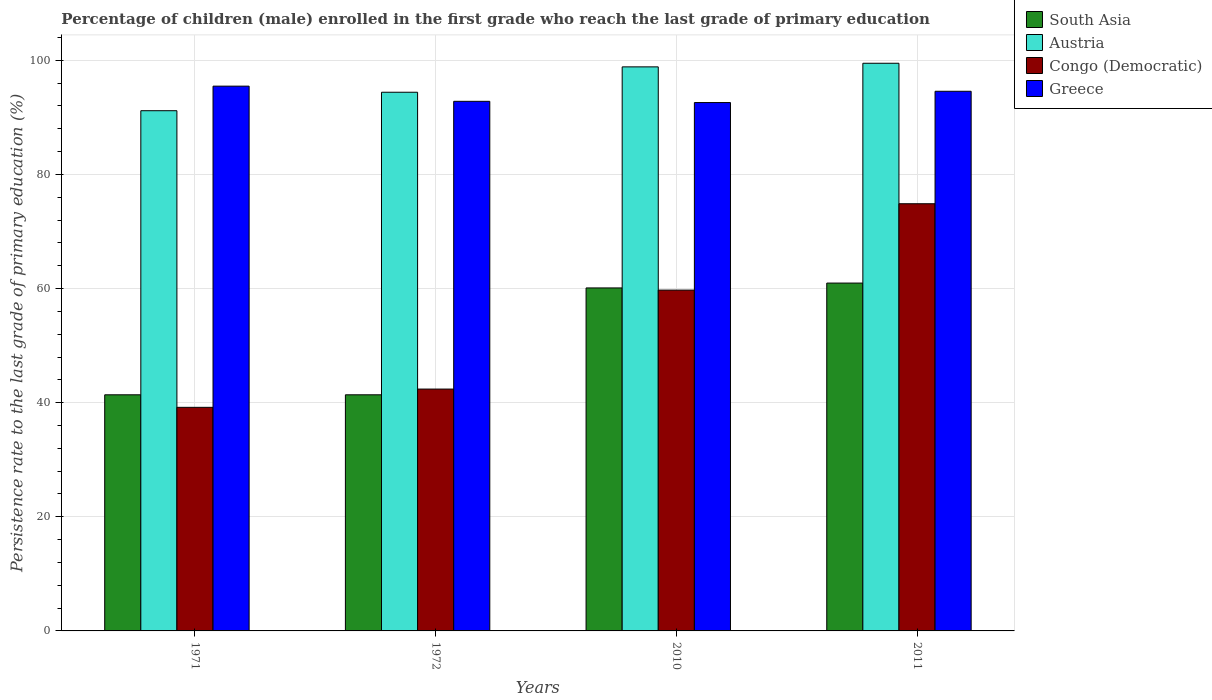How many different coloured bars are there?
Your answer should be very brief. 4. Are the number of bars on each tick of the X-axis equal?
Your response must be concise. Yes. How many bars are there on the 4th tick from the left?
Provide a short and direct response. 4. What is the persistence rate of children in Congo (Democratic) in 1972?
Offer a very short reply. 42.39. Across all years, what is the maximum persistence rate of children in Greece?
Your response must be concise. 95.48. Across all years, what is the minimum persistence rate of children in Congo (Democratic)?
Give a very brief answer. 39.19. In which year was the persistence rate of children in South Asia maximum?
Provide a short and direct response. 2011. In which year was the persistence rate of children in Congo (Democratic) minimum?
Offer a very short reply. 1971. What is the total persistence rate of children in Greece in the graph?
Give a very brief answer. 375.48. What is the difference between the persistence rate of children in South Asia in 1972 and that in 2011?
Offer a terse response. -19.58. What is the difference between the persistence rate of children in Austria in 2011 and the persistence rate of children in Congo (Democratic) in 2010?
Make the answer very short. 39.76. What is the average persistence rate of children in South Asia per year?
Offer a terse response. 50.96. In the year 2011, what is the difference between the persistence rate of children in Congo (Democratic) and persistence rate of children in Greece?
Your answer should be compact. -19.71. In how many years, is the persistence rate of children in Austria greater than 4 %?
Your answer should be compact. 4. What is the ratio of the persistence rate of children in Austria in 1972 to that in 2010?
Provide a succinct answer. 0.95. Is the difference between the persistence rate of children in Congo (Democratic) in 1971 and 2010 greater than the difference between the persistence rate of children in Greece in 1971 and 2010?
Provide a short and direct response. No. What is the difference between the highest and the second highest persistence rate of children in Austria?
Keep it short and to the point. 0.63. What is the difference between the highest and the lowest persistence rate of children in Greece?
Make the answer very short. 2.87. Is it the case that in every year, the sum of the persistence rate of children in Congo (Democratic) and persistence rate of children in South Asia is greater than the sum of persistence rate of children in Austria and persistence rate of children in Greece?
Offer a terse response. No. What does the 2nd bar from the left in 1972 represents?
Your answer should be very brief. Austria. What does the 3rd bar from the right in 2011 represents?
Your response must be concise. Austria. Is it the case that in every year, the sum of the persistence rate of children in Greece and persistence rate of children in Congo (Democratic) is greater than the persistence rate of children in Austria?
Your answer should be compact. Yes. Are all the bars in the graph horizontal?
Provide a succinct answer. No. How many years are there in the graph?
Provide a short and direct response. 4. What is the difference between two consecutive major ticks on the Y-axis?
Give a very brief answer. 20. Are the values on the major ticks of Y-axis written in scientific E-notation?
Give a very brief answer. No. Does the graph contain any zero values?
Offer a terse response. No. Does the graph contain grids?
Your answer should be compact. Yes. What is the title of the graph?
Give a very brief answer. Percentage of children (male) enrolled in the first grade who reach the last grade of primary education. What is the label or title of the X-axis?
Offer a very short reply. Years. What is the label or title of the Y-axis?
Your answer should be compact. Persistence rate to the last grade of primary education (%). What is the Persistence rate to the last grade of primary education (%) in South Asia in 1971?
Offer a very short reply. 41.38. What is the Persistence rate to the last grade of primary education (%) of Austria in 1971?
Your answer should be very brief. 91.17. What is the Persistence rate to the last grade of primary education (%) of Congo (Democratic) in 1971?
Provide a short and direct response. 39.19. What is the Persistence rate to the last grade of primary education (%) of Greece in 1971?
Ensure brevity in your answer.  95.48. What is the Persistence rate to the last grade of primary education (%) of South Asia in 1972?
Your answer should be compact. 41.38. What is the Persistence rate to the last grade of primary education (%) of Austria in 1972?
Your answer should be very brief. 94.41. What is the Persistence rate to the last grade of primary education (%) of Congo (Democratic) in 1972?
Provide a short and direct response. 42.39. What is the Persistence rate to the last grade of primary education (%) of Greece in 1972?
Give a very brief answer. 92.82. What is the Persistence rate to the last grade of primary education (%) in South Asia in 2010?
Make the answer very short. 60.11. What is the Persistence rate to the last grade of primary education (%) of Austria in 2010?
Make the answer very short. 98.86. What is the Persistence rate to the last grade of primary education (%) in Congo (Democratic) in 2010?
Offer a terse response. 59.73. What is the Persistence rate to the last grade of primary education (%) of Greece in 2010?
Your answer should be very brief. 92.6. What is the Persistence rate to the last grade of primary education (%) in South Asia in 2011?
Your response must be concise. 60.96. What is the Persistence rate to the last grade of primary education (%) in Austria in 2011?
Provide a short and direct response. 99.49. What is the Persistence rate to the last grade of primary education (%) in Congo (Democratic) in 2011?
Offer a very short reply. 74.87. What is the Persistence rate to the last grade of primary education (%) in Greece in 2011?
Provide a short and direct response. 94.58. Across all years, what is the maximum Persistence rate to the last grade of primary education (%) of South Asia?
Your answer should be very brief. 60.96. Across all years, what is the maximum Persistence rate to the last grade of primary education (%) of Austria?
Make the answer very short. 99.49. Across all years, what is the maximum Persistence rate to the last grade of primary education (%) of Congo (Democratic)?
Provide a short and direct response. 74.87. Across all years, what is the maximum Persistence rate to the last grade of primary education (%) in Greece?
Your answer should be compact. 95.48. Across all years, what is the minimum Persistence rate to the last grade of primary education (%) of South Asia?
Your answer should be compact. 41.38. Across all years, what is the minimum Persistence rate to the last grade of primary education (%) in Austria?
Your response must be concise. 91.17. Across all years, what is the minimum Persistence rate to the last grade of primary education (%) in Congo (Democratic)?
Make the answer very short. 39.19. Across all years, what is the minimum Persistence rate to the last grade of primary education (%) in Greece?
Provide a succinct answer. 92.6. What is the total Persistence rate to the last grade of primary education (%) of South Asia in the graph?
Your answer should be compact. 203.84. What is the total Persistence rate to the last grade of primary education (%) in Austria in the graph?
Provide a succinct answer. 383.93. What is the total Persistence rate to the last grade of primary education (%) in Congo (Democratic) in the graph?
Provide a succinct answer. 216.17. What is the total Persistence rate to the last grade of primary education (%) in Greece in the graph?
Give a very brief answer. 375.48. What is the difference between the Persistence rate to the last grade of primary education (%) in South Asia in 1971 and that in 1972?
Give a very brief answer. -0. What is the difference between the Persistence rate to the last grade of primary education (%) in Austria in 1971 and that in 1972?
Offer a very short reply. -3.24. What is the difference between the Persistence rate to the last grade of primary education (%) of Congo (Democratic) in 1971 and that in 1972?
Your response must be concise. -3.2. What is the difference between the Persistence rate to the last grade of primary education (%) in Greece in 1971 and that in 1972?
Your answer should be compact. 2.66. What is the difference between the Persistence rate to the last grade of primary education (%) in South Asia in 1971 and that in 2010?
Provide a succinct answer. -18.73. What is the difference between the Persistence rate to the last grade of primary education (%) of Austria in 1971 and that in 2010?
Offer a terse response. -7.68. What is the difference between the Persistence rate to the last grade of primary education (%) in Congo (Democratic) in 1971 and that in 2010?
Make the answer very short. -20.55. What is the difference between the Persistence rate to the last grade of primary education (%) in Greece in 1971 and that in 2010?
Your answer should be very brief. 2.87. What is the difference between the Persistence rate to the last grade of primary education (%) of South Asia in 1971 and that in 2011?
Offer a very short reply. -19.58. What is the difference between the Persistence rate to the last grade of primary education (%) in Austria in 1971 and that in 2011?
Your answer should be compact. -8.32. What is the difference between the Persistence rate to the last grade of primary education (%) of Congo (Democratic) in 1971 and that in 2011?
Ensure brevity in your answer.  -35.68. What is the difference between the Persistence rate to the last grade of primary education (%) in Greece in 1971 and that in 2011?
Provide a succinct answer. 0.9. What is the difference between the Persistence rate to the last grade of primary education (%) in South Asia in 1972 and that in 2010?
Offer a terse response. -18.73. What is the difference between the Persistence rate to the last grade of primary education (%) in Austria in 1972 and that in 2010?
Your response must be concise. -4.45. What is the difference between the Persistence rate to the last grade of primary education (%) of Congo (Democratic) in 1972 and that in 2010?
Provide a succinct answer. -17.34. What is the difference between the Persistence rate to the last grade of primary education (%) of Greece in 1972 and that in 2010?
Provide a succinct answer. 0.22. What is the difference between the Persistence rate to the last grade of primary education (%) in South Asia in 1972 and that in 2011?
Your answer should be compact. -19.58. What is the difference between the Persistence rate to the last grade of primary education (%) of Austria in 1972 and that in 2011?
Provide a succinct answer. -5.08. What is the difference between the Persistence rate to the last grade of primary education (%) of Congo (Democratic) in 1972 and that in 2011?
Your answer should be very brief. -32.48. What is the difference between the Persistence rate to the last grade of primary education (%) in Greece in 1972 and that in 2011?
Your answer should be compact. -1.76. What is the difference between the Persistence rate to the last grade of primary education (%) of South Asia in 2010 and that in 2011?
Make the answer very short. -0.85. What is the difference between the Persistence rate to the last grade of primary education (%) in Austria in 2010 and that in 2011?
Offer a very short reply. -0.63. What is the difference between the Persistence rate to the last grade of primary education (%) of Congo (Democratic) in 2010 and that in 2011?
Your answer should be very brief. -15.14. What is the difference between the Persistence rate to the last grade of primary education (%) in Greece in 2010 and that in 2011?
Your response must be concise. -1.98. What is the difference between the Persistence rate to the last grade of primary education (%) in South Asia in 1971 and the Persistence rate to the last grade of primary education (%) in Austria in 1972?
Offer a very short reply. -53.03. What is the difference between the Persistence rate to the last grade of primary education (%) of South Asia in 1971 and the Persistence rate to the last grade of primary education (%) of Congo (Democratic) in 1972?
Offer a terse response. -1.01. What is the difference between the Persistence rate to the last grade of primary education (%) of South Asia in 1971 and the Persistence rate to the last grade of primary education (%) of Greece in 1972?
Offer a very short reply. -51.44. What is the difference between the Persistence rate to the last grade of primary education (%) in Austria in 1971 and the Persistence rate to the last grade of primary education (%) in Congo (Democratic) in 1972?
Keep it short and to the point. 48.79. What is the difference between the Persistence rate to the last grade of primary education (%) in Austria in 1971 and the Persistence rate to the last grade of primary education (%) in Greece in 1972?
Make the answer very short. -1.65. What is the difference between the Persistence rate to the last grade of primary education (%) in Congo (Democratic) in 1971 and the Persistence rate to the last grade of primary education (%) in Greece in 1972?
Keep it short and to the point. -53.63. What is the difference between the Persistence rate to the last grade of primary education (%) in South Asia in 1971 and the Persistence rate to the last grade of primary education (%) in Austria in 2010?
Your response must be concise. -57.48. What is the difference between the Persistence rate to the last grade of primary education (%) in South Asia in 1971 and the Persistence rate to the last grade of primary education (%) in Congo (Democratic) in 2010?
Keep it short and to the point. -18.35. What is the difference between the Persistence rate to the last grade of primary education (%) of South Asia in 1971 and the Persistence rate to the last grade of primary education (%) of Greece in 2010?
Give a very brief answer. -51.22. What is the difference between the Persistence rate to the last grade of primary education (%) of Austria in 1971 and the Persistence rate to the last grade of primary education (%) of Congo (Democratic) in 2010?
Give a very brief answer. 31.44. What is the difference between the Persistence rate to the last grade of primary education (%) in Austria in 1971 and the Persistence rate to the last grade of primary education (%) in Greece in 2010?
Your answer should be compact. -1.43. What is the difference between the Persistence rate to the last grade of primary education (%) in Congo (Democratic) in 1971 and the Persistence rate to the last grade of primary education (%) in Greece in 2010?
Make the answer very short. -53.42. What is the difference between the Persistence rate to the last grade of primary education (%) in South Asia in 1971 and the Persistence rate to the last grade of primary education (%) in Austria in 2011?
Your response must be concise. -58.11. What is the difference between the Persistence rate to the last grade of primary education (%) in South Asia in 1971 and the Persistence rate to the last grade of primary education (%) in Congo (Democratic) in 2011?
Your answer should be very brief. -33.49. What is the difference between the Persistence rate to the last grade of primary education (%) of South Asia in 1971 and the Persistence rate to the last grade of primary education (%) of Greece in 2011?
Offer a terse response. -53.2. What is the difference between the Persistence rate to the last grade of primary education (%) of Austria in 1971 and the Persistence rate to the last grade of primary education (%) of Congo (Democratic) in 2011?
Your answer should be very brief. 16.3. What is the difference between the Persistence rate to the last grade of primary education (%) in Austria in 1971 and the Persistence rate to the last grade of primary education (%) in Greece in 2011?
Your answer should be very brief. -3.41. What is the difference between the Persistence rate to the last grade of primary education (%) of Congo (Democratic) in 1971 and the Persistence rate to the last grade of primary education (%) of Greece in 2011?
Ensure brevity in your answer.  -55.39. What is the difference between the Persistence rate to the last grade of primary education (%) of South Asia in 1972 and the Persistence rate to the last grade of primary education (%) of Austria in 2010?
Ensure brevity in your answer.  -57.47. What is the difference between the Persistence rate to the last grade of primary education (%) of South Asia in 1972 and the Persistence rate to the last grade of primary education (%) of Congo (Democratic) in 2010?
Provide a succinct answer. -18.35. What is the difference between the Persistence rate to the last grade of primary education (%) in South Asia in 1972 and the Persistence rate to the last grade of primary education (%) in Greece in 2010?
Keep it short and to the point. -51.22. What is the difference between the Persistence rate to the last grade of primary education (%) in Austria in 1972 and the Persistence rate to the last grade of primary education (%) in Congo (Democratic) in 2010?
Make the answer very short. 34.68. What is the difference between the Persistence rate to the last grade of primary education (%) of Austria in 1972 and the Persistence rate to the last grade of primary education (%) of Greece in 2010?
Keep it short and to the point. 1.81. What is the difference between the Persistence rate to the last grade of primary education (%) in Congo (Democratic) in 1972 and the Persistence rate to the last grade of primary education (%) in Greece in 2010?
Provide a succinct answer. -50.22. What is the difference between the Persistence rate to the last grade of primary education (%) in South Asia in 1972 and the Persistence rate to the last grade of primary education (%) in Austria in 2011?
Make the answer very short. -58.11. What is the difference between the Persistence rate to the last grade of primary education (%) of South Asia in 1972 and the Persistence rate to the last grade of primary education (%) of Congo (Democratic) in 2011?
Your answer should be compact. -33.49. What is the difference between the Persistence rate to the last grade of primary education (%) in South Asia in 1972 and the Persistence rate to the last grade of primary education (%) in Greece in 2011?
Make the answer very short. -53.2. What is the difference between the Persistence rate to the last grade of primary education (%) in Austria in 1972 and the Persistence rate to the last grade of primary education (%) in Congo (Democratic) in 2011?
Offer a very short reply. 19.54. What is the difference between the Persistence rate to the last grade of primary education (%) in Austria in 1972 and the Persistence rate to the last grade of primary education (%) in Greece in 2011?
Ensure brevity in your answer.  -0.17. What is the difference between the Persistence rate to the last grade of primary education (%) in Congo (Democratic) in 1972 and the Persistence rate to the last grade of primary education (%) in Greece in 2011?
Provide a succinct answer. -52.19. What is the difference between the Persistence rate to the last grade of primary education (%) in South Asia in 2010 and the Persistence rate to the last grade of primary education (%) in Austria in 2011?
Your response must be concise. -39.38. What is the difference between the Persistence rate to the last grade of primary education (%) in South Asia in 2010 and the Persistence rate to the last grade of primary education (%) in Congo (Democratic) in 2011?
Your answer should be very brief. -14.76. What is the difference between the Persistence rate to the last grade of primary education (%) in South Asia in 2010 and the Persistence rate to the last grade of primary education (%) in Greece in 2011?
Keep it short and to the point. -34.47. What is the difference between the Persistence rate to the last grade of primary education (%) of Austria in 2010 and the Persistence rate to the last grade of primary education (%) of Congo (Democratic) in 2011?
Your answer should be compact. 23.99. What is the difference between the Persistence rate to the last grade of primary education (%) in Austria in 2010 and the Persistence rate to the last grade of primary education (%) in Greece in 2011?
Your response must be concise. 4.28. What is the difference between the Persistence rate to the last grade of primary education (%) in Congo (Democratic) in 2010 and the Persistence rate to the last grade of primary education (%) in Greece in 2011?
Offer a very short reply. -34.85. What is the average Persistence rate to the last grade of primary education (%) of South Asia per year?
Provide a succinct answer. 50.96. What is the average Persistence rate to the last grade of primary education (%) in Austria per year?
Your answer should be compact. 95.98. What is the average Persistence rate to the last grade of primary education (%) of Congo (Democratic) per year?
Offer a terse response. 54.04. What is the average Persistence rate to the last grade of primary education (%) of Greece per year?
Offer a very short reply. 93.87. In the year 1971, what is the difference between the Persistence rate to the last grade of primary education (%) of South Asia and Persistence rate to the last grade of primary education (%) of Austria?
Offer a very short reply. -49.79. In the year 1971, what is the difference between the Persistence rate to the last grade of primary education (%) of South Asia and Persistence rate to the last grade of primary education (%) of Congo (Democratic)?
Your response must be concise. 2.2. In the year 1971, what is the difference between the Persistence rate to the last grade of primary education (%) in South Asia and Persistence rate to the last grade of primary education (%) in Greece?
Give a very brief answer. -54.09. In the year 1971, what is the difference between the Persistence rate to the last grade of primary education (%) of Austria and Persistence rate to the last grade of primary education (%) of Congo (Democratic)?
Your answer should be compact. 51.99. In the year 1971, what is the difference between the Persistence rate to the last grade of primary education (%) of Austria and Persistence rate to the last grade of primary education (%) of Greece?
Give a very brief answer. -4.3. In the year 1971, what is the difference between the Persistence rate to the last grade of primary education (%) in Congo (Democratic) and Persistence rate to the last grade of primary education (%) in Greece?
Provide a short and direct response. -56.29. In the year 1972, what is the difference between the Persistence rate to the last grade of primary education (%) in South Asia and Persistence rate to the last grade of primary education (%) in Austria?
Ensure brevity in your answer.  -53.03. In the year 1972, what is the difference between the Persistence rate to the last grade of primary education (%) of South Asia and Persistence rate to the last grade of primary education (%) of Congo (Democratic)?
Offer a very short reply. -1. In the year 1972, what is the difference between the Persistence rate to the last grade of primary education (%) of South Asia and Persistence rate to the last grade of primary education (%) of Greece?
Provide a short and direct response. -51.44. In the year 1972, what is the difference between the Persistence rate to the last grade of primary education (%) of Austria and Persistence rate to the last grade of primary education (%) of Congo (Democratic)?
Give a very brief answer. 52.02. In the year 1972, what is the difference between the Persistence rate to the last grade of primary education (%) of Austria and Persistence rate to the last grade of primary education (%) of Greece?
Your answer should be compact. 1.59. In the year 1972, what is the difference between the Persistence rate to the last grade of primary education (%) of Congo (Democratic) and Persistence rate to the last grade of primary education (%) of Greece?
Make the answer very short. -50.43. In the year 2010, what is the difference between the Persistence rate to the last grade of primary education (%) in South Asia and Persistence rate to the last grade of primary education (%) in Austria?
Provide a short and direct response. -38.75. In the year 2010, what is the difference between the Persistence rate to the last grade of primary education (%) of South Asia and Persistence rate to the last grade of primary education (%) of Congo (Democratic)?
Offer a terse response. 0.38. In the year 2010, what is the difference between the Persistence rate to the last grade of primary education (%) in South Asia and Persistence rate to the last grade of primary education (%) in Greece?
Provide a succinct answer. -32.49. In the year 2010, what is the difference between the Persistence rate to the last grade of primary education (%) of Austria and Persistence rate to the last grade of primary education (%) of Congo (Democratic)?
Offer a terse response. 39.13. In the year 2010, what is the difference between the Persistence rate to the last grade of primary education (%) of Austria and Persistence rate to the last grade of primary education (%) of Greece?
Provide a succinct answer. 6.25. In the year 2010, what is the difference between the Persistence rate to the last grade of primary education (%) of Congo (Democratic) and Persistence rate to the last grade of primary education (%) of Greece?
Your answer should be very brief. -32.87. In the year 2011, what is the difference between the Persistence rate to the last grade of primary education (%) in South Asia and Persistence rate to the last grade of primary education (%) in Austria?
Keep it short and to the point. -38.53. In the year 2011, what is the difference between the Persistence rate to the last grade of primary education (%) of South Asia and Persistence rate to the last grade of primary education (%) of Congo (Democratic)?
Your answer should be compact. -13.9. In the year 2011, what is the difference between the Persistence rate to the last grade of primary education (%) of South Asia and Persistence rate to the last grade of primary education (%) of Greece?
Provide a short and direct response. -33.62. In the year 2011, what is the difference between the Persistence rate to the last grade of primary education (%) of Austria and Persistence rate to the last grade of primary education (%) of Congo (Democratic)?
Offer a terse response. 24.62. In the year 2011, what is the difference between the Persistence rate to the last grade of primary education (%) in Austria and Persistence rate to the last grade of primary education (%) in Greece?
Make the answer very short. 4.91. In the year 2011, what is the difference between the Persistence rate to the last grade of primary education (%) of Congo (Democratic) and Persistence rate to the last grade of primary education (%) of Greece?
Offer a terse response. -19.71. What is the ratio of the Persistence rate to the last grade of primary education (%) in Austria in 1971 to that in 1972?
Ensure brevity in your answer.  0.97. What is the ratio of the Persistence rate to the last grade of primary education (%) of Congo (Democratic) in 1971 to that in 1972?
Your answer should be very brief. 0.92. What is the ratio of the Persistence rate to the last grade of primary education (%) of Greece in 1971 to that in 1972?
Ensure brevity in your answer.  1.03. What is the ratio of the Persistence rate to the last grade of primary education (%) in South Asia in 1971 to that in 2010?
Give a very brief answer. 0.69. What is the ratio of the Persistence rate to the last grade of primary education (%) in Austria in 1971 to that in 2010?
Offer a very short reply. 0.92. What is the ratio of the Persistence rate to the last grade of primary education (%) in Congo (Democratic) in 1971 to that in 2010?
Provide a succinct answer. 0.66. What is the ratio of the Persistence rate to the last grade of primary education (%) of Greece in 1971 to that in 2010?
Your answer should be compact. 1.03. What is the ratio of the Persistence rate to the last grade of primary education (%) in South Asia in 1971 to that in 2011?
Your response must be concise. 0.68. What is the ratio of the Persistence rate to the last grade of primary education (%) in Austria in 1971 to that in 2011?
Provide a succinct answer. 0.92. What is the ratio of the Persistence rate to the last grade of primary education (%) in Congo (Democratic) in 1971 to that in 2011?
Give a very brief answer. 0.52. What is the ratio of the Persistence rate to the last grade of primary education (%) in Greece in 1971 to that in 2011?
Give a very brief answer. 1.01. What is the ratio of the Persistence rate to the last grade of primary education (%) in South Asia in 1972 to that in 2010?
Your answer should be compact. 0.69. What is the ratio of the Persistence rate to the last grade of primary education (%) of Austria in 1972 to that in 2010?
Give a very brief answer. 0.95. What is the ratio of the Persistence rate to the last grade of primary education (%) in Congo (Democratic) in 1972 to that in 2010?
Provide a short and direct response. 0.71. What is the ratio of the Persistence rate to the last grade of primary education (%) in Greece in 1972 to that in 2010?
Provide a succinct answer. 1. What is the ratio of the Persistence rate to the last grade of primary education (%) of South Asia in 1972 to that in 2011?
Your answer should be very brief. 0.68. What is the ratio of the Persistence rate to the last grade of primary education (%) of Austria in 1972 to that in 2011?
Your answer should be compact. 0.95. What is the ratio of the Persistence rate to the last grade of primary education (%) in Congo (Democratic) in 1972 to that in 2011?
Offer a terse response. 0.57. What is the ratio of the Persistence rate to the last grade of primary education (%) of Greece in 1972 to that in 2011?
Your response must be concise. 0.98. What is the ratio of the Persistence rate to the last grade of primary education (%) of Congo (Democratic) in 2010 to that in 2011?
Keep it short and to the point. 0.8. What is the ratio of the Persistence rate to the last grade of primary education (%) of Greece in 2010 to that in 2011?
Offer a terse response. 0.98. What is the difference between the highest and the second highest Persistence rate to the last grade of primary education (%) in South Asia?
Provide a short and direct response. 0.85. What is the difference between the highest and the second highest Persistence rate to the last grade of primary education (%) in Austria?
Your answer should be very brief. 0.63. What is the difference between the highest and the second highest Persistence rate to the last grade of primary education (%) of Congo (Democratic)?
Provide a short and direct response. 15.14. What is the difference between the highest and the second highest Persistence rate to the last grade of primary education (%) in Greece?
Offer a terse response. 0.9. What is the difference between the highest and the lowest Persistence rate to the last grade of primary education (%) of South Asia?
Your response must be concise. 19.58. What is the difference between the highest and the lowest Persistence rate to the last grade of primary education (%) in Austria?
Make the answer very short. 8.32. What is the difference between the highest and the lowest Persistence rate to the last grade of primary education (%) in Congo (Democratic)?
Offer a terse response. 35.68. What is the difference between the highest and the lowest Persistence rate to the last grade of primary education (%) of Greece?
Ensure brevity in your answer.  2.87. 